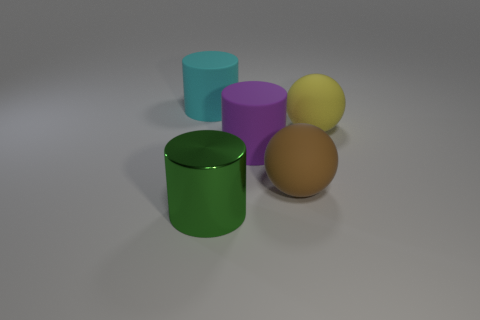Add 4 green cylinders. How many objects exist? 9 Subtract all brown cylinders. Subtract all purple spheres. How many cylinders are left? 3 Subtract 0 red blocks. How many objects are left? 5 Subtract all cylinders. How many objects are left? 2 Subtract all big purple things. Subtract all large cyan objects. How many objects are left? 3 Add 2 big purple cylinders. How many big purple cylinders are left? 3 Add 4 cyan matte cylinders. How many cyan matte cylinders exist? 5 